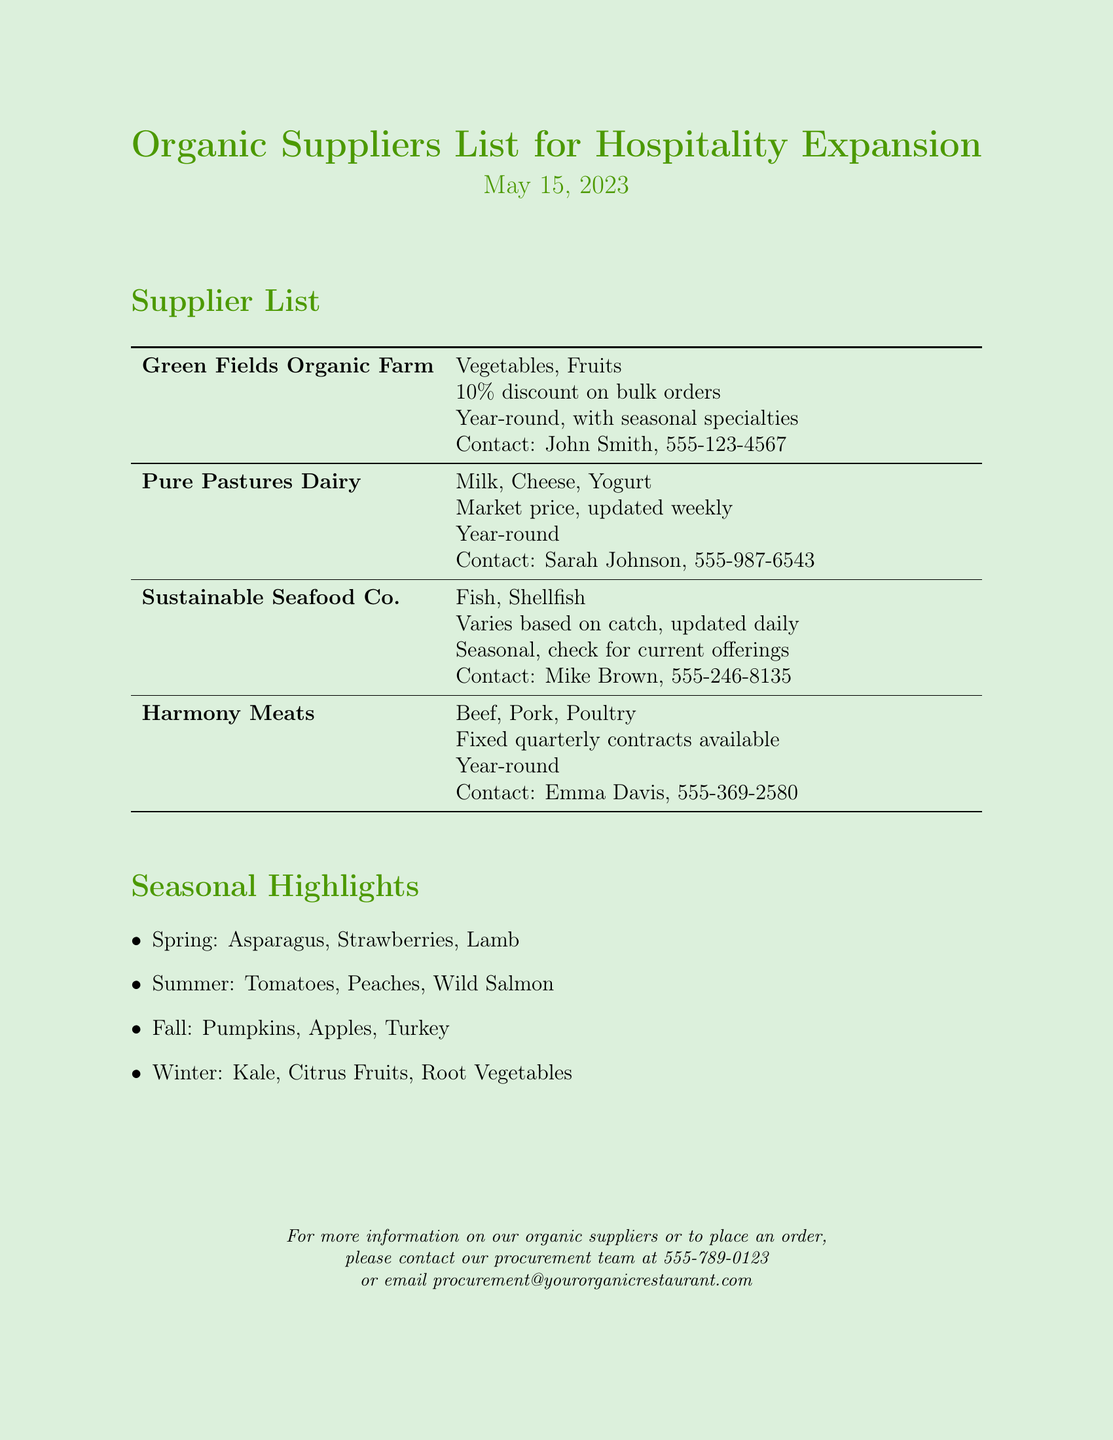what is the name of the first supplier? The first supplier listed in the document is "Green Fields Organic Farm".
Answer: Green Fields Organic Farm what type of products does Pure Pastures Dairy offer? The document specifies that Pure Pastures Dairy offers "Milk, Cheese, Yogurt".
Answer: Milk, Cheese, Yogurt who is the contact person for Sustainable Seafood Co.? The document includes the contact person for Sustainable Seafood Co. as "Mike Brown".
Answer: Mike Brown what is the discount offered by Green Fields Organic Farm? The document states that Green Fields Organic Farm offers a "10% discount on bulk orders".
Answer: 10% discount on bulk orders how often is the pricing updated for Pure Pastures Dairy? The document mentions that the pricing for Pure Pastures Dairy is "updated weekly".
Answer: updated weekly which seasonal highlights are available in winter? The document lists the winter seasonal highlights as "Kale, Citrus Fruits, Root Vegetables".
Answer: Kale, Citrus Fruits, Root Vegetables what type of contracts does Harmony Meats offer? The document notes that Harmony Meats offers "Fixed quarterly contracts available".
Answer: Fixed quarterly contracts what is the primary use of the document? The document is designed for establishing a list of organic suppliers for a specific business purpose.
Answer: Organic suppliers list who should be contacted for more information on organic suppliers? The document provides the contact information for the procurement team for inquiries about organic suppliers.
Answer: procurement team 